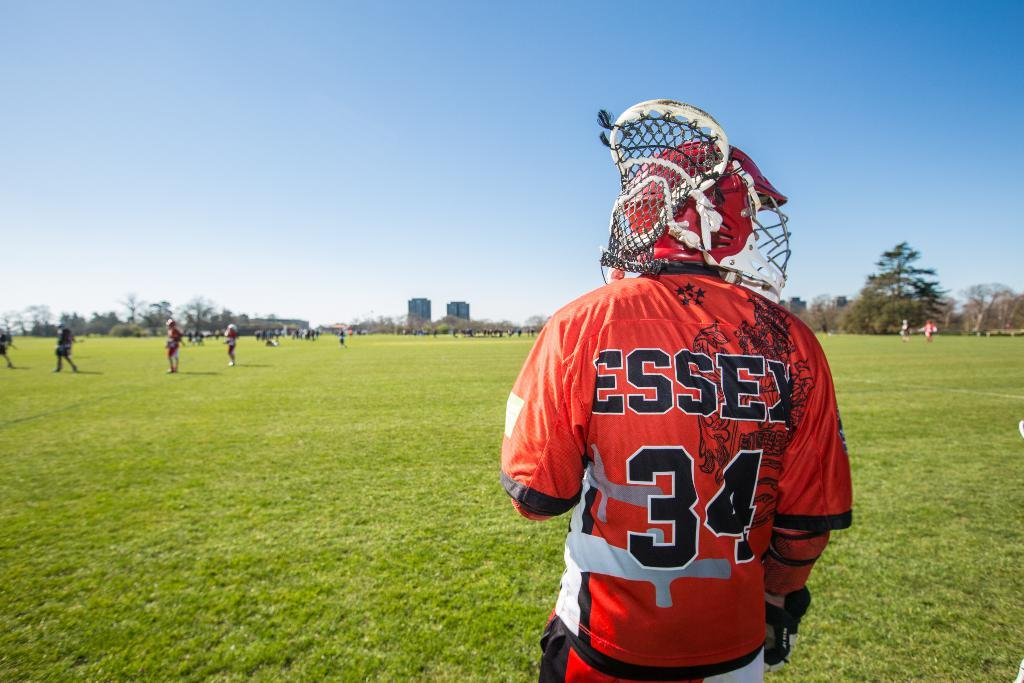What is the main subject of the image? There is a man standing in the image. What is the man wearing on his head? The man is wearing a helmet. What can be seen in the background of the image? There are people, trees, buildings, and the sky visible in the background of the image. Reasoning: Let' Let's think step by step in order to produce the conversation. We start by identifying the main subject of the image, which is the man standing. Then, we describe the man's attire, specifically mentioning the helmet he is wearing. Finally, we expand the conversation to include the background of the image, noting the presence of people, trees, buildings, and the sky. Absurd Question/Answer: What type of breath can be seen coming from the man's mouth in the image? There is no visible breath coming from the man's mouth in the image. What type of servant is present in the image? There is no servant present in the image. 